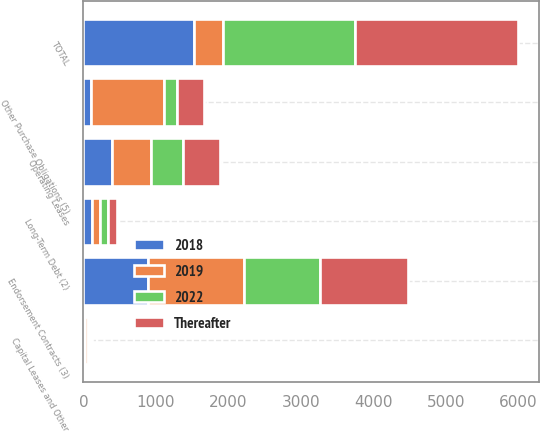Convert chart to OTSL. <chart><loc_0><loc_0><loc_500><loc_500><stacked_bar_chart><ecel><fcel>Operating Leases<fcel>Capital Leases and Other<fcel>Long-Term Debt (2)<fcel>Endorsement Contracts (3)<fcel>Other Purchase Obligations (5)<fcel>TOTAL<nl><fcel>2019<fcel>537<fcel>34<fcel>115<fcel>1323<fcel>1000<fcel>399<nl><fcel>Thereafter<fcel>509<fcel>32<fcel>115<fcel>1214<fcel>373<fcel>2243<nl><fcel>2022<fcel>438<fcel>28<fcel>115<fcel>1054<fcel>182<fcel>1817<nl><fcel>2018<fcel>399<fcel>25<fcel>112<fcel>889<fcel>106<fcel>1531<nl></chart> 